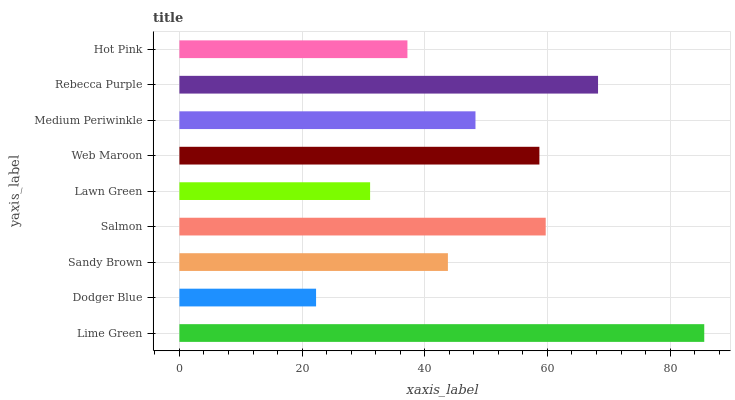Is Dodger Blue the minimum?
Answer yes or no. Yes. Is Lime Green the maximum?
Answer yes or no. Yes. Is Sandy Brown the minimum?
Answer yes or no. No. Is Sandy Brown the maximum?
Answer yes or no. No. Is Sandy Brown greater than Dodger Blue?
Answer yes or no. Yes. Is Dodger Blue less than Sandy Brown?
Answer yes or no. Yes. Is Dodger Blue greater than Sandy Brown?
Answer yes or no. No. Is Sandy Brown less than Dodger Blue?
Answer yes or no. No. Is Medium Periwinkle the high median?
Answer yes or no. Yes. Is Medium Periwinkle the low median?
Answer yes or no. Yes. Is Lawn Green the high median?
Answer yes or no. No. Is Salmon the low median?
Answer yes or no. No. 